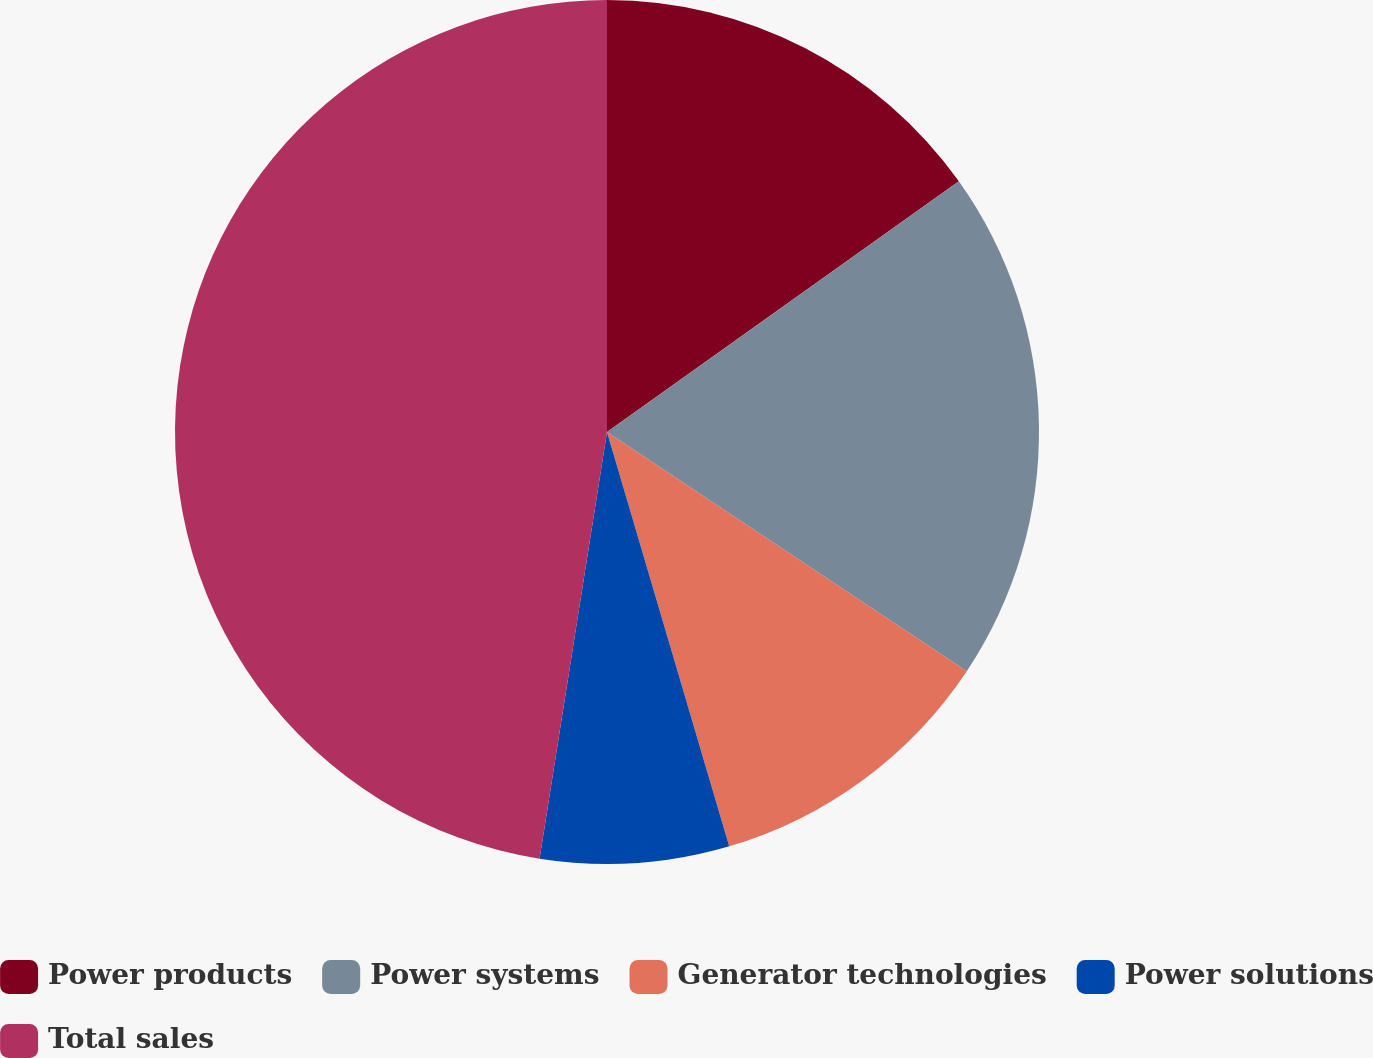<chart> <loc_0><loc_0><loc_500><loc_500><pie_chart><fcel>Power products<fcel>Power systems<fcel>Generator technologies<fcel>Power solutions<fcel>Total sales<nl><fcel>15.15%<fcel>19.19%<fcel>11.1%<fcel>7.06%<fcel>47.51%<nl></chart> 